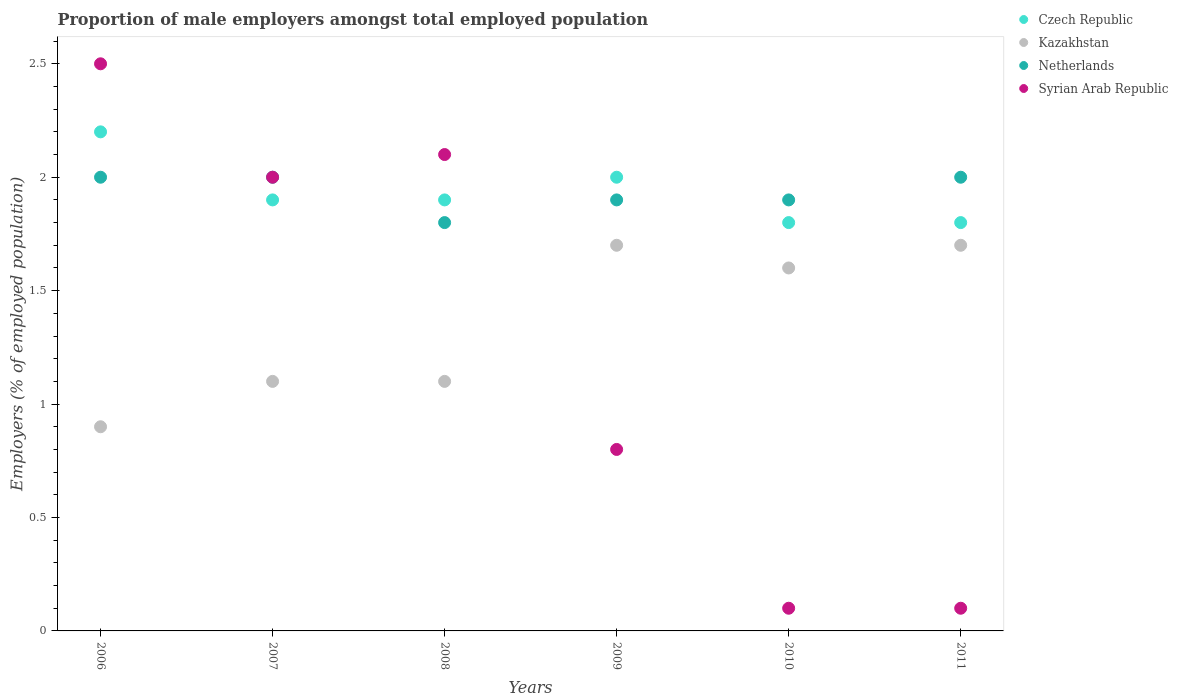What is the proportion of male employers in Syrian Arab Republic in 2011?
Keep it short and to the point. 0.1. Across all years, what is the maximum proportion of male employers in Czech Republic?
Offer a terse response. 2.2. Across all years, what is the minimum proportion of male employers in Kazakhstan?
Your answer should be very brief. 0.9. What is the total proportion of male employers in Netherlands in the graph?
Give a very brief answer. 11.6. What is the difference between the proportion of male employers in Syrian Arab Republic in 2008 and that in 2011?
Make the answer very short. 2. What is the difference between the proportion of male employers in Netherlands in 2010 and the proportion of male employers in Kazakhstan in 2007?
Your answer should be compact. 0.8. What is the average proportion of male employers in Syrian Arab Republic per year?
Give a very brief answer. 1.27. In the year 2009, what is the difference between the proportion of male employers in Czech Republic and proportion of male employers in Syrian Arab Republic?
Your response must be concise. 1.2. What is the ratio of the proportion of male employers in Kazakhstan in 2008 to that in 2011?
Your response must be concise. 0.65. Is the difference between the proportion of male employers in Czech Republic in 2008 and 2009 greater than the difference between the proportion of male employers in Syrian Arab Republic in 2008 and 2009?
Ensure brevity in your answer.  No. What is the difference between the highest and the lowest proportion of male employers in Syrian Arab Republic?
Keep it short and to the point. 2.4. In how many years, is the proportion of male employers in Netherlands greater than the average proportion of male employers in Netherlands taken over all years?
Keep it short and to the point. 3. Is the sum of the proportion of male employers in Czech Republic in 2006 and 2011 greater than the maximum proportion of male employers in Kazakhstan across all years?
Provide a short and direct response. Yes. Is it the case that in every year, the sum of the proportion of male employers in Czech Republic and proportion of male employers in Netherlands  is greater than the proportion of male employers in Kazakhstan?
Give a very brief answer. Yes. Does the proportion of male employers in Kazakhstan monotonically increase over the years?
Provide a succinct answer. No. Is the proportion of male employers in Kazakhstan strictly greater than the proportion of male employers in Czech Republic over the years?
Offer a very short reply. No. How many years are there in the graph?
Offer a terse response. 6. What is the difference between two consecutive major ticks on the Y-axis?
Offer a very short reply. 0.5. Does the graph contain any zero values?
Make the answer very short. No. How are the legend labels stacked?
Offer a very short reply. Vertical. What is the title of the graph?
Your response must be concise. Proportion of male employers amongst total employed population. What is the label or title of the X-axis?
Offer a terse response. Years. What is the label or title of the Y-axis?
Offer a terse response. Employers (% of employed population). What is the Employers (% of employed population) of Czech Republic in 2006?
Provide a short and direct response. 2.2. What is the Employers (% of employed population) in Kazakhstan in 2006?
Ensure brevity in your answer.  0.9. What is the Employers (% of employed population) of Netherlands in 2006?
Your response must be concise. 2. What is the Employers (% of employed population) in Czech Republic in 2007?
Keep it short and to the point. 1.9. What is the Employers (% of employed population) of Kazakhstan in 2007?
Offer a terse response. 1.1. What is the Employers (% of employed population) in Syrian Arab Republic in 2007?
Give a very brief answer. 2. What is the Employers (% of employed population) in Czech Republic in 2008?
Your answer should be compact. 1.9. What is the Employers (% of employed population) of Kazakhstan in 2008?
Make the answer very short. 1.1. What is the Employers (% of employed population) of Netherlands in 2008?
Offer a terse response. 1.8. What is the Employers (% of employed population) in Syrian Arab Republic in 2008?
Provide a short and direct response. 2.1. What is the Employers (% of employed population) in Czech Republic in 2009?
Keep it short and to the point. 2. What is the Employers (% of employed population) of Kazakhstan in 2009?
Give a very brief answer. 1.7. What is the Employers (% of employed population) of Netherlands in 2009?
Your answer should be compact. 1.9. What is the Employers (% of employed population) in Syrian Arab Republic in 2009?
Your response must be concise. 0.8. What is the Employers (% of employed population) in Czech Republic in 2010?
Your answer should be compact. 1.8. What is the Employers (% of employed population) of Kazakhstan in 2010?
Your answer should be very brief. 1.6. What is the Employers (% of employed population) of Netherlands in 2010?
Ensure brevity in your answer.  1.9. What is the Employers (% of employed population) in Syrian Arab Republic in 2010?
Keep it short and to the point. 0.1. What is the Employers (% of employed population) of Czech Republic in 2011?
Keep it short and to the point. 1.8. What is the Employers (% of employed population) of Kazakhstan in 2011?
Give a very brief answer. 1.7. What is the Employers (% of employed population) of Netherlands in 2011?
Your response must be concise. 2. What is the Employers (% of employed population) in Syrian Arab Republic in 2011?
Offer a very short reply. 0.1. Across all years, what is the maximum Employers (% of employed population) in Czech Republic?
Give a very brief answer. 2.2. Across all years, what is the maximum Employers (% of employed population) of Kazakhstan?
Keep it short and to the point. 1.7. Across all years, what is the maximum Employers (% of employed population) in Syrian Arab Republic?
Make the answer very short. 2.5. Across all years, what is the minimum Employers (% of employed population) of Czech Republic?
Offer a terse response. 1.8. Across all years, what is the minimum Employers (% of employed population) of Kazakhstan?
Provide a short and direct response. 0.9. Across all years, what is the minimum Employers (% of employed population) in Netherlands?
Your answer should be very brief. 1.8. Across all years, what is the minimum Employers (% of employed population) of Syrian Arab Republic?
Offer a terse response. 0.1. What is the total Employers (% of employed population) in Netherlands in the graph?
Your response must be concise. 11.6. What is the total Employers (% of employed population) of Syrian Arab Republic in the graph?
Give a very brief answer. 7.6. What is the difference between the Employers (% of employed population) in Czech Republic in 2006 and that in 2007?
Offer a very short reply. 0.3. What is the difference between the Employers (% of employed population) of Kazakhstan in 2006 and that in 2007?
Provide a short and direct response. -0.2. What is the difference between the Employers (% of employed population) of Netherlands in 2006 and that in 2007?
Give a very brief answer. 0. What is the difference between the Employers (% of employed population) of Syrian Arab Republic in 2006 and that in 2007?
Ensure brevity in your answer.  0.5. What is the difference between the Employers (% of employed population) of Czech Republic in 2006 and that in 2008?
Make the answer very short. 0.3. What is the difference between the Employers (% of employed population) of Kazakhstan in 2006 and that in 2008?
Offer a very short reply. -0.2. What is the difference between the Employers (% of employed population) in Kazakhstan in 2006 and that in 2009?
Provide a short and direct response. -0.8. What is the difference between the Employers (% of employed population) in Netherlands in 2006 and that in 2009?
Give a very brief answer. 0.1. What is the difference between the Employers (% of employed population) of Czech Republic in 2006 and that in 2010?
Make the answer very short. 0.4. What is the difference between the Employers (% of employed population) of Syrian Arab Republic in 2006 and that in 2010?
Make the answer very short. 2.4. What is the difference between the Employers (% of employed population) in Czech Republic in 2007 and that in 2008?
Offer a terse response. 0. What is the difference between the Employers (% of employed population) of Kazakhstan in 2007 and that in 2008?
Your answer should be compact. 0. What is the difference between the Employers (% of employed population) in Czech Republic in 2007 and that in 2009?
Provide a succinct answer. -0.1. What is the difference between the Employers (% of employed population) in Kazakhstan in 2007 and that in 2009?
Give a very brief answer. -0.6. What is the difference between the Employers (% of employed population) in Syrian Arab Republic in 2007 and that in 2009?
Give a very brief answer. 1.2. What is the difference between the Employers (% of employed population) in Czech Republic in 2007 and that in 2010?
Make the answer very short. 0.1. What is the difference between the Employers (% of employed population) in Kazakhstan in 2007 and that in 2011?
Offer a very short reply. -0.6. What is the difference between the Employers (% of employed population) of Netherlands in 2007 and that in 2011?
Provide a short and direct response. 0. What is the difference between the Employers (% of employed population) in Syrian Arab Republic in 2007 and that in 2011?
Ensure brevity in your answer.  1.9. What is the difference between the Employers (% of employed population) in Kazakhstan in 2008 and that in 2009?
Ensure brevity in your answer.  -0.6. What is the difference between the Employers (% of employed population) in Netherlands in 2008 and that in 2009?
Your answer should be very brief. -0.1. What is the difference between the Employers (% of employed population) in Syrian Arab Republic in 2008 and that in 2009?
Your answer should be compact. 1.3. What is the difference between the Employers (% of employed population) of Czech Republic in 2009 and that in 2010?
Your response must be concise. 0.2. What is the difference between the Employers (% of employed population) in Netherlands in 2009 and that in 2010?
Provide a succinct answer. 0. What is the difference between the Employers (% of employed population) of Czech Republic in 2009 and that in 2011?
Give a very brief answer. 0.2. What is the difference between the Employers (% of employed population) of Kazakhstan in 2009 and that in 2011?
Keep it short and to the point. 0. What is the difference between the Employers (% of employed population) in Syrian Arab Republic in 2009 and that in 2011?
Your answer should be compact. 0.7. What is the difference between the Employers (% of employed population) in Czech Republic in 2010 and that in 2011?
Provide a succinct answer. 0. What is the difference between the Employers (% of employed population) of Kazakhstan in 2010 and that in 2011?
Provide a short and direct response. -0.1. What is the difference between the Employers (% of employed population) of Netherlands in 2010 and that in 2011?
Your answer should be compact. -0.1. What is the difference between the Employers (% of employed population) of Syrian Arab Republic in 2010 and that in 2011?
Ensure brevity in your answer.  0. What is the difference between the Employers (% of employed population) of Czech Republic in 2006 and the Employers (% of employed population) of Kazakhstan in 2007?
Give a very brief answer. 1.1. What is the difference between the Employers (% of employed population) in Czech Republic in 2006 and the Employers (% of employed population) in Netherlands in 2007?
Offer a terse response. 0.2. What is the difference between the Employers (% of employed population) in Czech Republic in 2006 and the Employers (% of employed population) in Syrian Arab Republic in 2007?
Keep it short and to the point. 0.2. What is the difference between the Employers (% of employed population) of Kazakhstan in 2006 and the Employers (% of employed population) of Syrian Arab Republic in 2008?
Offer a very short reply. -1.2. What is the difference between the Employers (% of employed population) of Czech Republic in 2006 and the Employers (% of employed population) of Kazakhstan in 2009?
Give a very brief answer. 0.5. What is the difference between the Employers (% of employed population) in Kazakhstan in 2006 and the Employers (% of employed population) in Netherlands in 2009?
Your answer should be very brief. -1. What is the difference between the Employers (% of employed population) in Kazakhstan in 2006 and the Employers (% of employed population) in Syrian Arab Republic in 2009?
Your answer should be compact. 0.1. What is the difference between the Employers (% of employed population) in Netherlands in 2006 and the Employers (% of employed population) in Syrian Arab Republic in 2009?
Keep it short and to the point. 1.2. What is the difference between the Employers (% of employed population) in Czech Republic in 2006 and the Employers (% of employed population) in Syrian Arab Republic in 2010?
Offer a terse response. 2.1. What is the difference between the Employers (% of employed population) in Czech Republic in 2006 and the Employers (% of employed population) in Netherlands in 2011?
Make the answer very short. 0.2. What is the difference between the Employers (% of employed population) of Czech Republic in 2006 and the Employers (% of employed population) of Syrian Arab Republic in 2011?
Ensure brevity in your answer.  2.1. What is the difference between the Employers (% of employed population) in Czech Republic in 2007 and the Employers (% of employed population) in Kazakhstan in 2008?
Offer a terse response. 0.8. What is the difference between the Employers (% of employed population) of Czech Republic in 2007 and the Employers (% of employed population) of Netherlands in 2008?
Keep it short and to the point. 0.1. What is the difference between the Employers (% of employed population) in Czech Republic in 2007 and the Employers (% of employed population) in Syrian Arab Republic in 2008?
Make the answer very short. -0.2. What is the difference between the Employers (% of employed population) in Kazakhstan in 2007 and the Employers (% of employed population) in Syrian Arab Republic in 2008?
Your response must be concise. -1. What is the difference between the Employers (% of employed population) in Netherlands in 2007 and the Employers (% of employed population) in Syrian Arab Republic in 2008?
Keep it short and to the point. -0.1. What is the difference between the Employers (% of employed population) of Czech Republic in 2007 and the Employers (% of employed population) of Kazakhstan in 2009?
Your answer should be compact. 0.2. What is the difference between the Employers (% of employed population) in Czech Republic in 2007 and the Employers (% of employed population) in Netherlands in 2009?
Ensure brevity in your answer.  0. What is the difference between the Employers (% of employed population) in Netherlands in 2007 and the Employers (% of employed population) in Syrian Arab Republic in 2009?
Give a very brief answer. 1.2. What is the difference between the Employers (% of employed population) in Czech Republic in 2007 and the Employers (% of employed population) in Kazakhstan in 2010?
Give a very brief answer. 0.3. What is the difference between the Employers (% of employed population) in Czech Republic in 2007 and the Employers (% of employed population) in Netherlands in 2010?
Keep it short and to the point. 0. What is the difference between the Employers (% of employed population) in Czech Republic in 2007 and the Employers (% of employed population) in Syrian Arab Republic in 2010?
Your answer should be very brief. 1.8. What is the difference between the Employers (% of employed population) in Czech Republic in 2007 and the Employers (% of employed population) in Kazakhstan in 2011?
Provide a short and direct response. 0.2. What is the difference between the Employers (% of employed population) in Kazakhstan in 2007 and the Employers (% of employed population) in Syrian Arab Republic in 2011?
Provide a succinct answer. 1. What is the difference between the Employers (% of employed population) in Netherlands in 2007 and the Employers (% of employed population) in Syrian Arab Republic in 2011?
Your answer should be very brief. 1.9. What is the difference between the Employers (% of employed population) of Czech Republic in 2008 and the Employers (% of employed population) of Kazakhstan in 2009?
Your answer should be compact. 0.2. What is the difference between the Employers (% of employed population) in Czech Republic in 2008 and the Employers (% of employed population) in Syrian Arab Republic in 2009?
Your response must be concise. 1.1. What is the difference between the Employers (% of employed population) in Kazakhstan in 2008 and the Employers (% of employed population) in Netherlands in 2009?
Make the answer very short. -0.8. What is the difference between the Employers (% of employed population) of Kazakhstan in 2008 and the Employers (% of employed population) of Syrian Arab Republic in 2009?
Provide a succinct answer. 0.3. What is the difference between the Employers (% of employed population) in Czech Republic in 2008 and the Employers (% of employed population) in Syrian Arab Republic in 2010?
Offer a very short reply. 1.8. What is the difference between the Employers (% of employed population) of Czech Republic in 2008 and the Employers (% of employed population) of Netherlands in 2011?
Give a very brief answer. -0.1. What is the difference between the Employers (% of employed population) in Kazakhstan in 2008 and the Employers (% of employed population) in Netherlands in 2011?
Keep it short and to the point. -0.9. What is the difference between the Employers (% of employed population) of Czech Republic in 2009 and the Employers (% of employed population) of Kazakhstan in 2010?
Ensure brevity in your answer.  0.4. What is the difference between the Employers (% of employed population) of Czech Republic in 2009 and the Employers (% of employed population) of Netherlands in 2010?
Your answer should be very brief. 0.1. What is the difference between the Employers (% of employed population) of Czech Republic in 2010 and the Employers (% of employed population) of Netherlands in 2011?
Ensure brevity in your answer.  -0.2. What is the difference between the Employers (% of employed population) in Kazakhstan in 2010 and the Employers (% of employed population) in Netherlands in 2011?
Make the answer very short. -0.4. What is the difference between the Employers (% of employed population) in Kazakhstan in 2010 and the Employers (% of employed population) in Syrian Arab Republic in 2011?
Offer a very short reply. 1.5. What is the average Employers (% of employed population) of Czech Republic per year?
Give a very brief answer. 1.93. What is the average Employers (% of employed population) of Kazakhstan per year?
Ensure brevity in your answer.  1.35. What is the average Employers (% of employed population) of Netherlands per year?
Provide a short and direct response. 1.93. What is the average Employers (% of employed population) in Syrian Arab Republic per year?
Keep it short and to the point. 1.27. In the year 2006, what is the difference between the Employers (% of employed population) of Kazakhstan and Employers (% of employed population) of Syrian Arab Republic?
Your answer should be very brief. -1.6. In the year 2007, what is the difference between the Employers (% of employed population) of Czech Republic and Employers (% of employed population) of Kazakhstan?
Give a very brief answer. 0.8. In the year 2007, what is the difference between the Employers (% of employed population) in Czech Republic and Employers (% of employed population) in Syrian Arab Republic?
Offer a very short reply. -0.1. In the year 2007, what is the difference between the Employers (% of employed population) of Kazakhstan and Employers (% of employed population) of Netherlands?
Offer a very short reply. -0.9. In the year 2008, what is the difference between the Employers (% of employed population) of Czech Republic and Employers (% of employed population) of Kazakhstan?
Your answer should be compact. 0.8. In the year 2008, what is the difference between the Employers (% of employed population) of Czech Republic and Employers (% of employed population) of Netherlands?
Provide a short and direct response. 0.1. In the year 2008, what is the difference between the Employers (% of employed population) of Kazakhstan and Employers (% of employed population) of Syrian Arab Republic?
Make the answer very short. -1. In the year 2009, what is the difference between the Employers (% of employed population) in Czech Republic and Employers (% of employed population) in Netherlands?
Your answer should be compact. 0.1. In the year 2009, what is the difference between the Employers (% of employed population) in Kazakhstan and Employers (% of employed population) in Netherlands?
Ensure brevity in your answer.  -0.2. In the year 2009, what is the difference between the Employers (% of employed population) in Kazakhstan and Employers (% of employed population) in Syrian Arab Republic?
Give a very brief answer. 0.9. In the year 2009, what is the difference between the Employers (% of employed population) of Netherlands and Employers (% of employed population) of Syrian Arab Republic?
Offer a very short reply. 1.1. In the year 2010, what is the difference between the Employers (% of employed population) of Kazakhstan and Employers (% of employed population) of Syrian Arab Republic?
Your response must be concise. 1.5. In the year 2010, what is the difference between the Employers (% of employed population) in Netherlands and Employers (% of employed population) in Syrian Arab Republic?
Offer a very short reply. 1.8. In the year 2011, what is the difference between the Employers (% of employed population) of Czech Republic and Employers (% of employed population) of Kazakhstan?
Provide a succinct answer. 0.1. What is the ratio of the Employers (% of employed population) in Czech Republic in 2006 to that in 2007?
Your response must be concise. 1.16. What is the ratio of the Employers (% of employed population) in Kazakhstan in 2006 to that in 2007?
Make the answer very short. 0.82. What is the ratio of the Employers (% of employed population) in Syrian Arab Republic in 2006 to that in 2007?
Offer a very short reply. 1.25. What is the ratio of the Employers (% of employed population) of Czech Republic in 2006 to that in 2008?
Provide a short and direct response. 1.16. What is the ratio of the Employers (% of employed population) in Kazakhstan in 2006 to that in 2008?
Provide a succinct answer. 0.82. What is the ratio of the Employers (% of employed population) in Syrian Arab Republic in 2006 to that in 2008?
Provide a short and direct response. 1.19. What is the ratio of the Employers (% of employed population) of Czech Republic in 2006 to that in 2009?
Offer a very short reply. 1.1. What is the ratio of the Employers (% of employed population) in Kazakhstan in 2006 to that in 2009?
Your response must be concise. 0.53. What is the ratio of the Employers (% of employed population) of Netherlands in 2006 to that in 2009?
Your response must be concise. 1.05. What is the ratio of the Employers (% of employed population) of Syrian Arab Republic in 2006 to that in 2009?
Make the answer very short. 3.12. What is the ratio of the Employers (% of employed population) in Czech Republic in 2006 to that in 2010?
Keep it short and to the point. 1.22. What is the ratio of the Employers (% of employed population) in Kazakhstan in 2006 to that in 2010?
Offer a terse response. 0.56. What is the ratio of the Employers (% of employed population) in Netherlands in 2006 to that in 2010?
Your answer should be very brief. 1.05. What is the ratio of the Employers (% of employed population) in Syrian Arab Republic in 2006 to that in 2010?
Give a very brief answer. 25. What is the ratio of the Employers (% of employed population) in Czech Republic in 2006 to that in 2011?
Offer a terse response. 1.22. What is the ratio of the Employers (% of employed population) in Kazakhstan in 2006 to that in 2011?
Make the answer very short. 0.53. What is the ratio of the Employers (% of employed population) in Czech Republic in 2007 to that in 2009?
Ensure brevity in your answer.  0.95. What is the ratio of the Employers (% of employed population) of Kazakhstan in 2007 to that in 2009?
Your answer should be compact. 0.65. What is the ratio of the Employers (% of employed population) in Netherlands in 2007 to that in 2009?
Ensure brevity in your answer.  1.05. What is the ratio of the Employers (% of employed population) of Czech Republic in 2007 to that in 2010?
Provide a short and direct response. 1.06. What is the ratio of the Employers (% of employed population) of Kazakhstan in 2007 to that in 2010?
Give a very brief answer. 0.69. What is the ratio of the Employers (% of employed population) of Netherlands in 2007 to that in 2010?
Keep it short and to the point. 1.05. What is the ratio of the Employers (% of employed population) in Syrian Arab Republic in 2007 to that in 2010?
Your answer should be compact. 20. What is the ratio of the Employers (% of employed population) in Czech Republic in 2007 to that in 2011?
Give a very brief answer. 1.06. What is the ratio of the Employers (% of employed population) of Kazakhstan in 2007 to that in 2011?
Your response must be concise. 0.65. What is the ratio of the Employers (% of employed population) in Syrian Arab Republic in 2007 to that in 2011?
Make the answer very short. 20. What is the ratio of the Employers (% of employed population) of Czech Republic in 2008 to that in 2009?
Your answer should be compact. 0.95. What is the ratio of the Employers (% of employed population) in Kazakhstan in 2008 to that in 2009?
Your answer should be compact. 0.65. What is the ratio of the Employers (% of employed population) in Netherlands in 2008 to that in 2009?
Ensure brevity in your answer.  0.95. What is the ratio of the Employers (% of employed population) of Syrian Arab Republic in 2008 to that in 2009?
Make the answer very short. 2.62. What is the ratio of the Employers (% of employed population) of Czech Republic in 2008 to that in 2010?
Make the answer very short. 1.06. What is the ratio of the Employers (% of employed population) of Kazakhstan in 2008 to that in 2010?
Your answer should be compact. 0.69. What is the ratio of the Employers (% of employed population) in Czech Republic in 2008 to that in 2011?
Ensure brevity in your answer.  1.06. What is the ratio of the Employers (% of employed population) of Kazakhstan in 2008 to that in 2011?
Offer a terse response. 0.65. What is the ratio of the Employers (% of employed population) in Syrian Arab Republic in 2008 to that in 2011?
Provide a short and direct response. 21. What is the ratio of the Employers (% of employed population) of Kazakhstan in 2009 to that in 2010?
Ensure brevity in your answer.  1.06. What is the ratio of the Employers (% of employed population) in Czech Republic in 2009 to that in 2011?
Provide a short and direct response. 1.11. What is the ratio of the Employers (% of employed population) in Netherlands in 2009 to that in 2011?
Keep it short and to the point. 0.95. What is the ratio of the Employers (% of employed population) of Syrian Arab Republic in 2009 to that in 2011?
Ensure brevity in your answer.  8. What is the ratio of the Employers (% of employed population) in Kazakhstan in 2010 to that in 2011?
Your answer should be very brief. 0.94. What is the ratio of the Employers (% of employed population) of Netherlands in 2010 to that in 2011?
Make the answer very short. 0.95. What is the difference between the highest and the second highest Employers (% of employed population) in Czech Republic?
Ensure brevity in your answer.  0.2. What is the difference between the highest and the second highest Employers (% of employed population) of Kazakhstan?
Ensure brevity in your answer.  0. What is the difference between the highest and the second highest Employers (% of employed population) of Netherlands?
Your answer should be compact. 0. What is the difference between the highest and the second highest Employers (% of employed population) in Syrian Arab Republic?
Make the answer very short. 0.4. What is the difference between the highest and the lowest Employers (% of employed population) in Kazakhstan?
Make the answer very short. 0.8. What is the difference between the highest and the lowest Employers (% of employed population) of Netherlands?
Your response must be concise. 0.2. What is the difference between the highest and the lowest Employers (% of employed population) of Syrian Arab Republic?
Offer a very short reply. 2.4. 